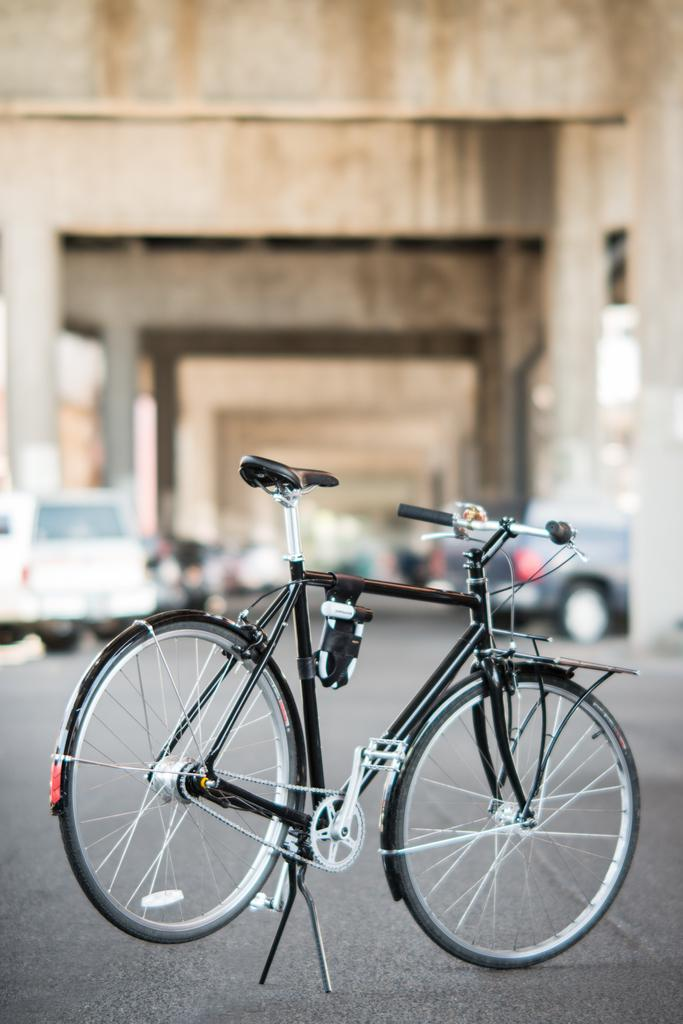What type of bicycle can be seen in the image? There is a black bicycle in the image. What else is visible in the background of the image? There are vehicles and pillars in the background of the image. Can you describe the color of the pillars? The pillars have cream and brown colors. How many girls are blowing bubbles in the image? There are no girls or bubbles present in the image. 